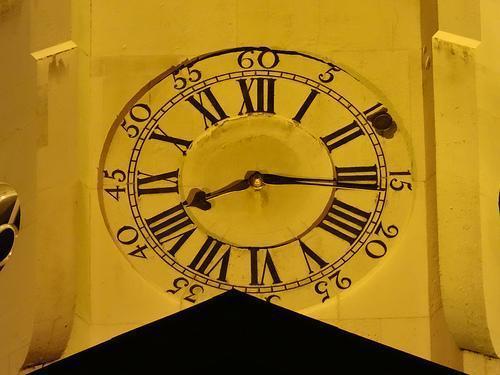How many clocks are there?
Give a very brief answer. 1. 